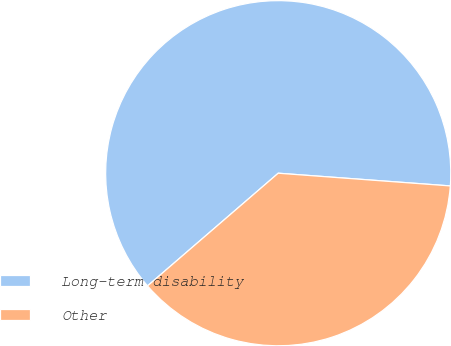Convert chart. <chart><loc_0><loc_0><loc_500><loc_500><pie_chart><fcel>Long-term disability<fcel>Other<nl><fcel>62.5%<fcel>37.5%<nl></chart> 